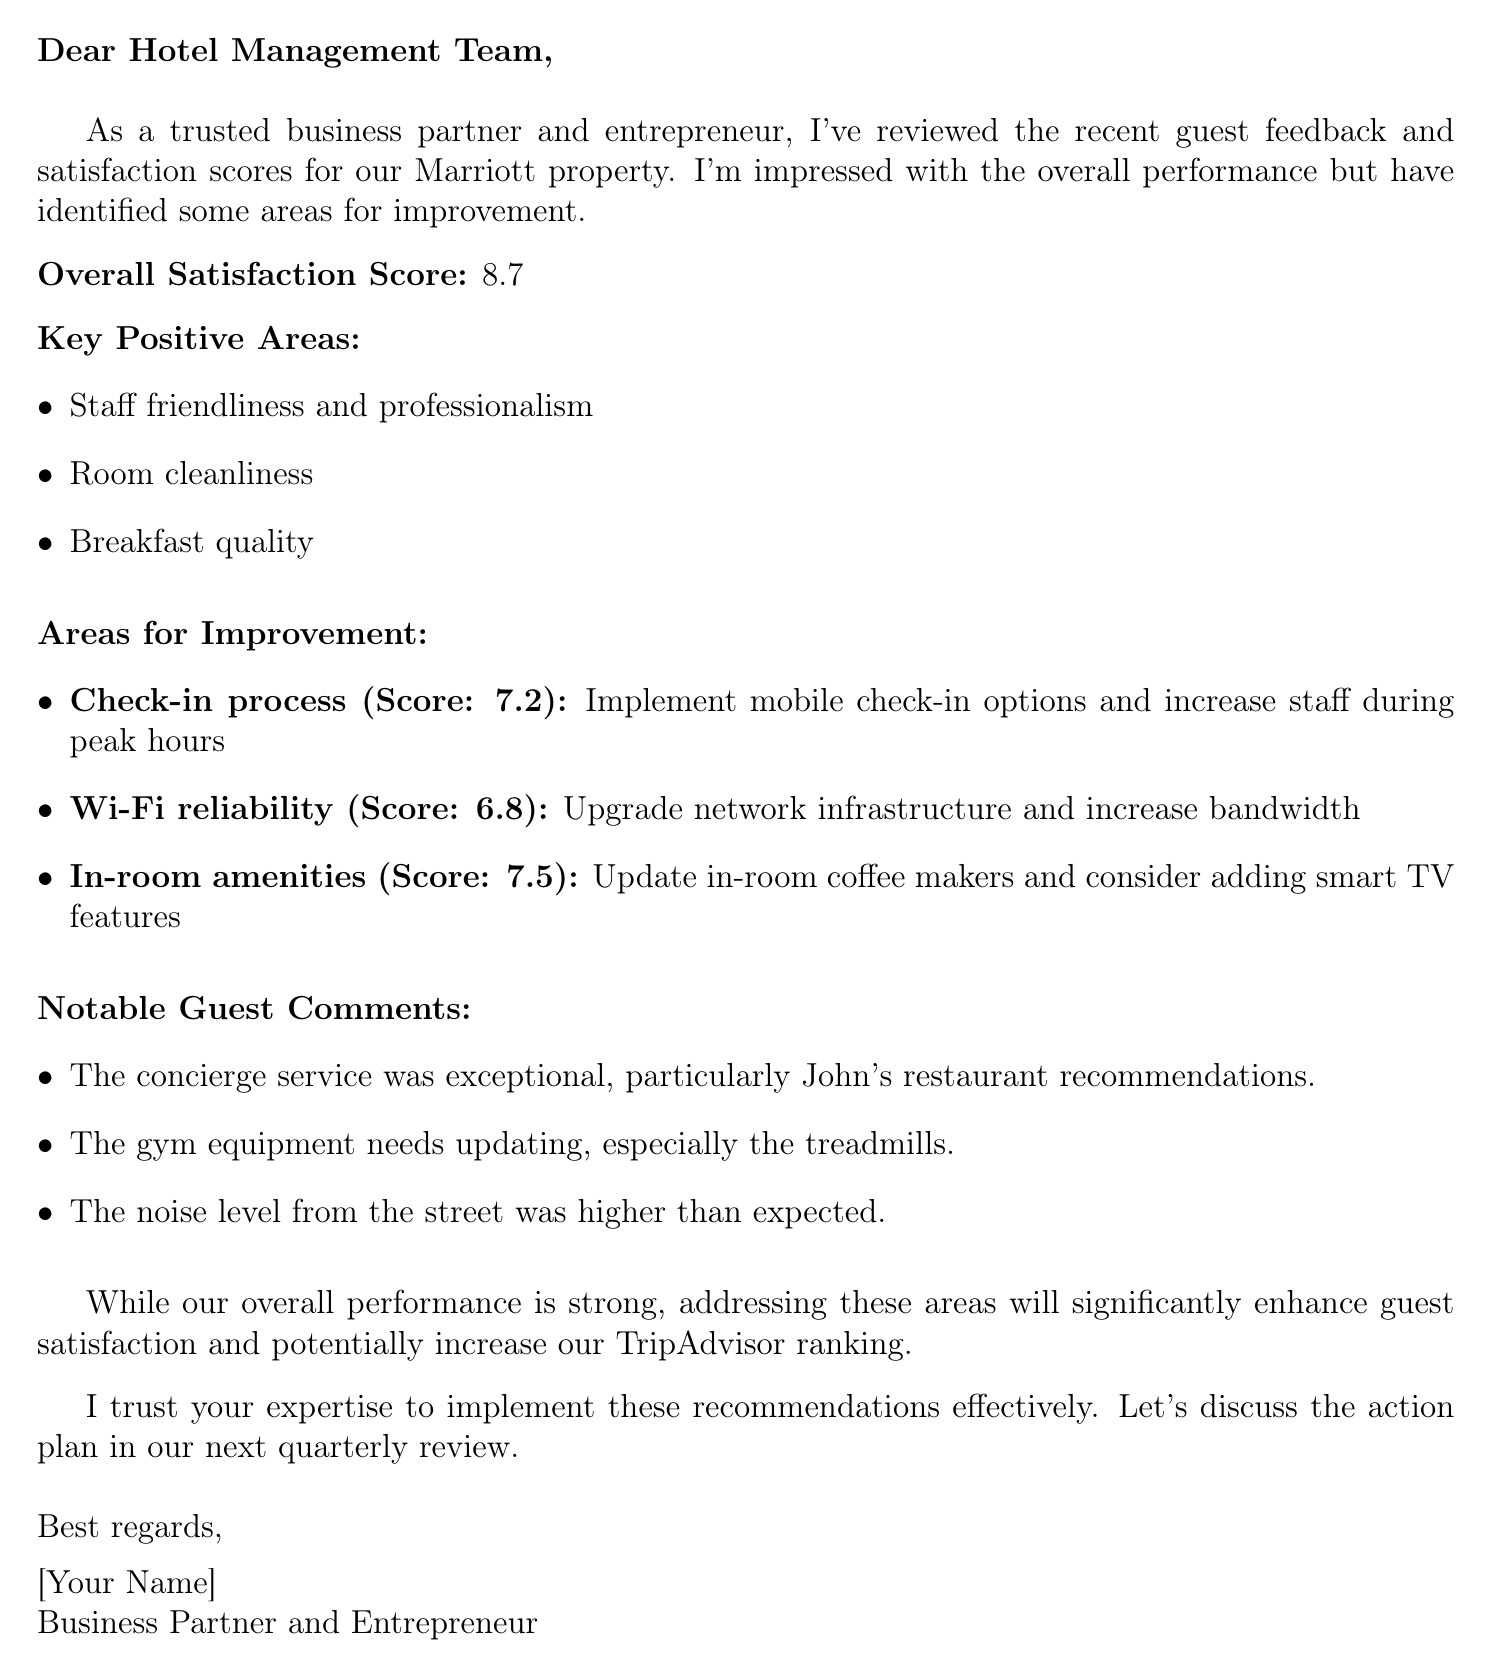what is the overall satisfaction score? The overall satisfaction score is explicitly stated in the document as a measure of guest satisfaction.
Answer: 8.7 what are the key positive areas mentioned? The document lists specific key positive areas that reflect strengths between guests and hotel services.
Answer: Staff friendliness and professionalism, Room cleanliness, Breakfast quality what is the score for Wi-Fi reliability? The score for Wi-Fi reliability is provided to indicate guest satisfaction with this particular service aspect.
Answer: 6.8 what is the recommendation for the check-in process? The recommendation for the check-in process outlines a suggestion for improving guest experience during arrival.
Answer: Implement mobile check-in options and increase staff during peak hours who provided exceptional concierge service? The document mentions a specific person who is credited with outstanding service in the concierge department.
Answer: John why is it important to address the areas for improvement? The text explains that enhancing these areas will lead to a better overall guest experience and higher rankings.
Answer: To significantly enhance guest satisfaction and potentially increase our TripAdvisor ranking what comment did a guest make about the gym? The document describes a specific guest feedback related to gym facilities, highlighting an area needing attention.
Answer: The gym equipment needs updating, especially the treadmills what is the tone of the conclusion? The conclusion summarizes the findings and indicates a forward-looking, proactive approach to improvements.
Answer: Proactive and trusting what action is suggested for in-room amenities? The recommendation for in-room amenities promotes updates to improve guest satisfaction with facilities in their rooms.
Answer: Update in-room coffee makers and consider adding smart TV features 